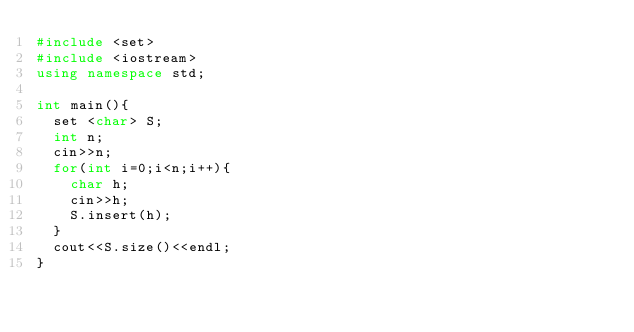Convert code to text. <code><loc_0><loc_0><loc_500><loc_500><_C++_>#include <set>
#include <iostream>
using namespace std;

int main(){
  set <char> S;
  int n;
  cin>>n;
  for(int i=0;i<n;i++){
    char h;
    cin>>h;
    S.insert(h);
  }
  cout<<S.size()<<endl;
}
</code> 